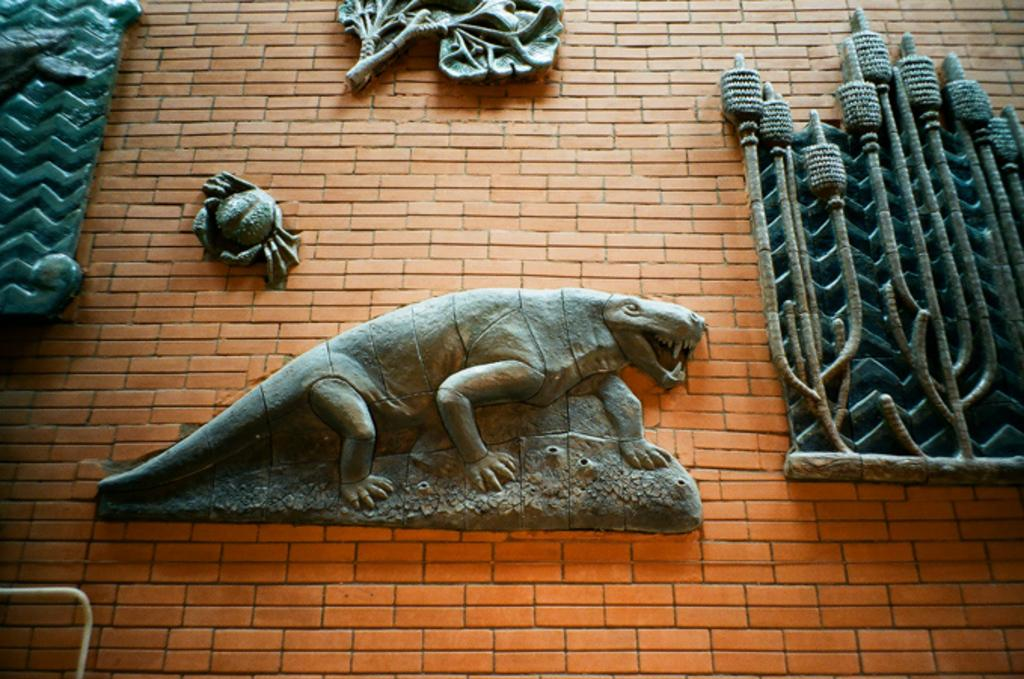What is present on the wall in the image? There are sculptures on the wall in the image. What type of sculptures can be seen on the wall? Some of the sculptures resemble animals. What type of creature is causing anger among the sculptures in the image? There is no creature present in the image, nor is there any indication of anger among the sculptures. 